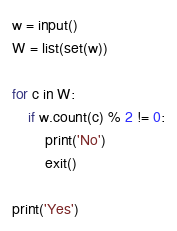Convert code to text. <code><loc_0><loc_0><loc_500><loc_500><_Python_>w = input()
W = list(set(w))
 
for c in W:
    if w.count(c) % 2 != 0:
        print('No')
        exit()
 
print('Yes')</code> 